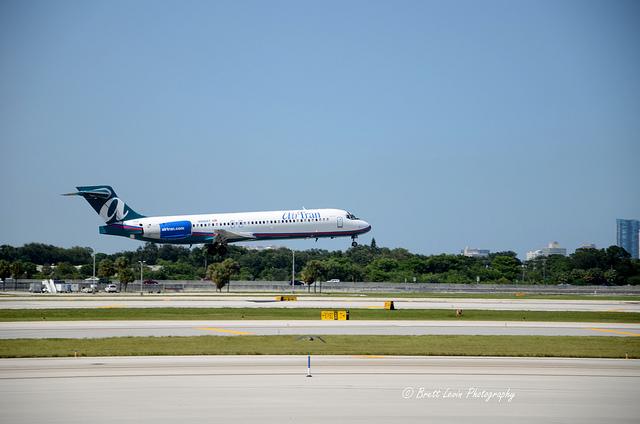Is the plane flying?
Keep it brief. Yes. How many planes are there?
Concise answer only. 1. What letter is on the tail?
Answer briefly. A. 